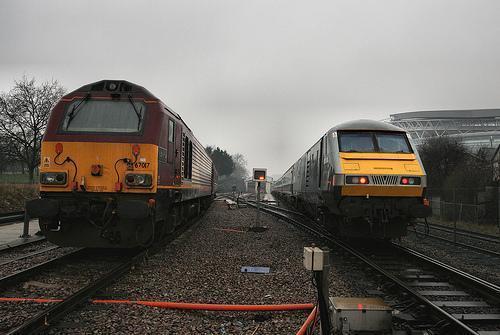How many trains are in the picture?
Give a very brief answer. 2. 